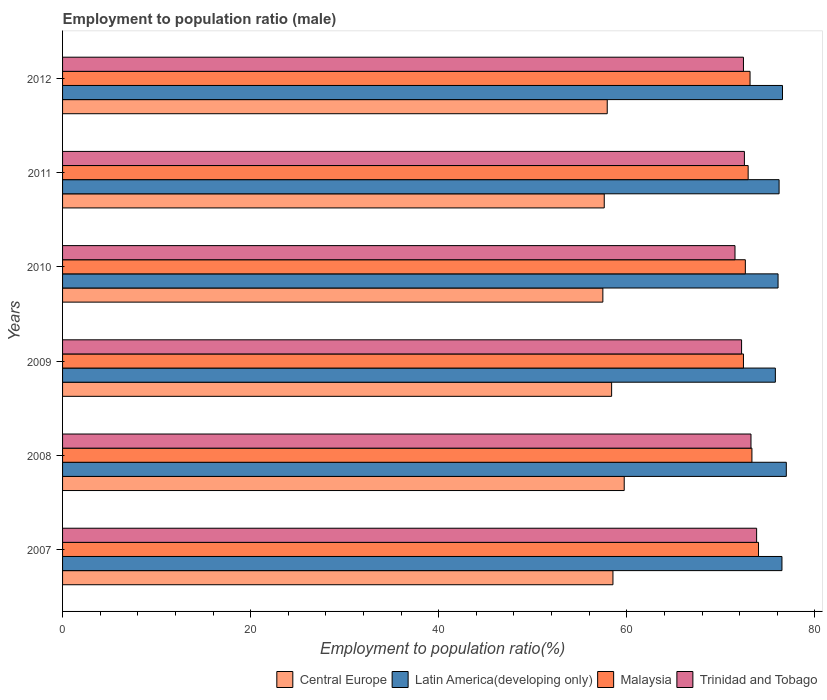How many groups of bars are there?
Your answer should be very brief. 6. Are the number of bars per tick equal to the number of legend labels?
Your answer should be very brief. Yes. How many bars are there on the 6th tick from the bottom?
Keep it short and to the point. 4. In how many cases, is the number of bars for a given year not equal to the number of legend labels?
Your answer should be very brief. 0. What is the employment to population ratio in Central Europe in 2012?
Offer a very short reply. 57.92. Across all years, what is the maximum employment to population ratio in Central Europe?
Provide a short and direct response. 59.72. Across all years, what is the minimum employment to population ratio in Central Europe?
Offer a terse response. 57.45. In which year was the employment to population ratio in Latin America(developing only) maximum?
Make the answer very short. 2008. In which year was the employment to population ratio in Latin America(developing only) minimum?
Provide a succinct answer. 2009. What is the total employment to population ratio in Malaysia in the graph?
Provide a short and direct response. 438.3. What is the difference between the employment to population ratio in Central Europe in 2008 and that in 2009?
Keep it short and to the point. 1.34. What is the difference between the employment to population ratio in Trinidad and Tobago in 2009 and the employment to population ratio in Latin America(developing only) in 2012?
Make the answer very short. -4.35. What is the average employment to population ratio in Central Europe per year?
Offer a very short reply. 58.26. In the year 2012, what is the difference between the employment to population ratio in Latin America(developing only) and employment to population ratio in Central Europe?
Your answer should be very brief. 18.63. In how many years, is the employment to population ratio in Malaysia greater than 28 %?
Ensure brevity in your answer.  6. What is the ratio of the employment to population ratio in Trinidad and Tobago in 2009 to that in 2010?
Offer a terse response. 1.01. Is the difference between the employment to population ratio in Latin America(developing only) in 2009 and 2011 greater than the difference between the employment to population ratio in Central Europe in 2009 and 2011?
Keep it short and to the point. No. What is the difference between the highest and the second highest employment to population ratio in Central Europe?
Your response must be concise. 1.2. What is the difference between the highest and the lowest employment to population ratio in Central Europe?
Offer a terse response. 2.27. In how many years, is the employment to population ratio in Trinidad and Tobago greater than the average employment to population ratio in Trinidad and Tobago taken over all years?
Ensure brevity in your answer.  2. Is the sum of the employment to population ratio in Malaysia in 2011 and 2012 greater than the maximum employment to population ratio in Central Europe across all years?
Give a very brief answer. Yes. Is it the case that in every year, the sum of the employment to population ratio in Central Europe and employment to population ratio in Latin America(developing only) is greater than the sum of employment to population ratio in Malaysia and employment to population ratio in Trinidad and Tobago?
Keep it short and to the point. Yes. What does the 3rd bar from the top in 2012 represents?
Keep it short and to the point. Latin America(developing only). What does the 3rd bar from the bottom in 2010 represents?
Ensure brevity in your answer.  Malaysia. How many bars are there?
Offer a very short reply. 24. Are all the bars in the graph horizontal?
Your answer should be very brief. Yes. How many years are there in the graph?
Your answer should be compact. 6. Are the values on the major ticks of X-axis written in scientific E-notation?
Provide a succinct answer. No. Does the graph contain any zero values?
Provide a short and direct response. No. How many legend labels are there?
Your answer should be compact. 4. What is the title of the graph?
Ensure brevity in your answer.  Employment to population ratio (male). What is the Employment to population ratio(%) in Central Europe in 2007?
Ensure brevity in your answer.  58.52. What is the Employment to population ratio(%) of Latin America(developing only) in 2007?
Your answer should be compact. 76.49. What is the Employment to population ratio(%) in Malaysia in 2007?
Your answer should be compact. 74. What is the Employment to population ratio(%) of Trinidad and Tobago in 2007?
Ensure brevity in your answer.  73.8. What is the Employment to population ratio(%) in Central Europe in 2008?
Your answer should be compact. 59.72. What is the Employment to population ratio(%) of Latin America(developing only) in 2008?
Give a very brief answer. 76.96. What is the Employment to population ratio(%) of Malaysia in 2008?
Provide a succinct answer. 73.3. What is the Employment to population ratio(%) of Trinidad and Tobago in 2008?
Keep it short and to the point. 73.2. What is the Employment to population ratio(%) in Central Europe in 2009?
Your response must be concise. 58.38. What is the Employment to population ratio(%) in Latin America(developing only) in 2009?
Your answer should be very brief. 75.79. What is the Employment to population ratio(%) in Malaysia in 2009?
Ensure brevity in your answer.  72.4. What is the Employment to population ratio(%) of Trinidad and Tobago in 2009?
Your answer should be very brief. 72.2. What is the Employment to population ratio(%) in Central Europe in 2010?
Ensure brevity in your answer.  57.45. What is the Employment to population ratio(%) in Latin America(developing only) in 2010?
Provide a short and direct response. 76.08. What is the Employment to population ratio(%) in Malaysia in 2010?
Ensure brevity in your answer.  72.6. What is the Employment to population ratio(%) of Trinidad and Tobago in 2010?
Make the answer very short. 71.5. What is the Employment to population ratio(%) of Central Europe in 2011?
Keep it short and to the point. 57.6. What is the Employment to population ratio(%) in Latin America(developing only) in 2011?
Your response must be concise. 76.19. What is the Employment to population ratio(%) in Malaysia in 2011?
Offer a terse response. 72.9. What is the Employment to population ratio(%) in Trinidad and Tobago in 2011?
Your answer should be compact. 72.5. What is the Employment to population ratio(%) of Central Europe in 2012?
Your response must be concise. 57.92. What is the Employment to population ratio(%) of Latin America(developing only) in 2012?
Your answer should be very brief. 76.55. What is the Employment to population ratio(%) in Malaysia in 2012?
Give a very brief answer. 73.1. What is the Employment to population ratio(%) in Trinidad and Tobago in 2012?
Your answer should be very brief. 72.4. Across all years, what is the maximum Employment to population ratio(%) in Central Europe?
Provide a succinct answer. 59.72. Across all years, what is the maximum Employment to population ratio(%) of Latin America(developing only)?
Ensure brevity in your answer.  76.96. Across all years, what is the maximum Employment to population ratio(%) of Trinidad and Tobago?
Offer a very short reply. 73.8. Across all years, what is the minimum Employment to population ratio(%) in Central Europe?
Keep it short and to the point. 57.45. Across all years, what is the minimum Employment to population ratio(%) of Latin America(developing only)?
Provide a succinct answer. 75.79. Across all years, what is the minimum Employment to population ratio(%) in Malaysia?
Give a very brief answer. 72.4. Across all years, what is the minimum Employment to population ratio(%) in Trinidad and Tobago?
Your response must be concise. 71.5. What is the total Employment to population ratio(%) of Central Europe in the graph?
Offer a terse response. 349.59. What is the total Employment to population ratio(%) in Latin America(developing only) in the graph?
Your answer should be compact. 458.06. What is the total Employment to population ratio(%) in Malaysia in the graph?
Offer a terse response. 438.3. What is the total Employment to population ratio(%) in Trinidad and Tobago in the graph?
Keep it short and to the point. 435.6. What is the difference between the Employment to population ratio(%) in Central Europe in 2007 and that in 2008?
Your response must be concise. -1.2. What is the difference between the Employment to population ratio(%) of Latin America(developing only) in 2007 and that in 2008?
Give a very brief answer. -0.46. What is the difference between the Employment to population ratio(%) of Malaysia in 2007 and that in 2008?
Provide a succinct answer. 0.7. What is the difference between the Employment to population ratio(%) in Central Europe in 2007 and that in 2009?
Your answer should be compact. 0.14. What is the difference between the Employment to population ratio(%) in Latin America(developing only) in 2007 and that in 2009?
Offer a very short reply. 0.7. What is the difference between the Employment to population ratio(%) in Malaysia in 2007 and that in 2009?
Ensure brevity in your answer.  1.6. What is the difference between the Employment to population ratio(%) in Central Europe in 2007 and that in 2010?
Offer a terse response. 1.07. What is the difference between the Employment to population ratio(%) in Latin America(developing only) in 2007 and that in 2010?
Your answer should be very brief. 0.41. What is the difference between the Employment to population ratio(%) of Malaysia in 2007 and that in 2010?
Your response must be concise. 1.4. What is the difference between the Employment to population ratio(%) in Trinidad and Tobago in 2007 and that in 2010?
Offer a terse response. 2.3. What is the difference between the Employment to population ratio(%) of Central Europe in 2007 and that in 2011?
Give a very brief answer. 0.92. What is the difference between the Employment to population ratio(%) of Latin America(developing only) in 2007 and that in 2011?
Offer a very short reply. 0.3. What is the difference between the Employment to population ratio(%) of Trinidad and Tobago in 2007 and that in 2011?
Ensure brevity in your answer.  1.3. What is the difference between the Employment to population ratio(%) of Central Europe in 2007 and that in 2012?
Provide a succinct answer. 0.61. What is the difference between the Employment to population ratio(%) of Latin America(developing only) in 2007 and that in 2012?
Keep it short and to the point. -0.06. What is the difference between the Employment to population ratio(%) in Malaysia in 2007 and that in 2012?
Provide a succinct answer. 0.9. What is the difference between the Employment to population ratio(%) of Trinidad and Tobago in 2007 and that in 2012?
Your answer should be compact. 1.4. What is the difference between the Employment to population ratio(%) of Central Europe in 2008 and that in 2009?
Make the answer very short. 1.34. What is the difference between the Employment to population ratio(%) of Latin America(developing only) in 2008 and that in 2009?
Ensure brevity in your answer.  1.16. What is the difference between the Employment to population ratio(%) of Central Europe in 2008 and that in 2010?
Your answer should be compact. 2.27. What is the difference between the Employment to population ratio(%) in Latin America(developing only) in 2008 and that in 2010?
Your answer should be very brief. 0.88. What is the difference between the Employment to population ratio(%) of Trinidad and Tobago in 2008 and that in 2010?
Give a very brief answer. 1.7. What is the difference between the Employment to population ratio(%) of Central Europe in 2008 and that in 2011?
Your answer should be compact. 2.12. What is the difference between the Employment to population ratio(%) in Latin America(developing only) in 2008 and that in 2011?
Offer a terse response. 0.77. What is the difference between the Employment to population ratio(%) of Trinidad and Tobago in 2008 and that in 2011?
Your response must be concise. 0.7. What is the difference between the Employment to population ratio(%) of Central Europe in 2008 and that in 2012?
Ensure brevity in your answer.  1.81. What is the difference between the Employment to population ratio(%) in Latin America(developing only) in 2008 and that in 2012?
Your response must be concise. 0.41. What is the difference between the Employment to population ratio(%) of Malaysia in 2008 and that in 2012?
Your answer should be compact. 0.2. What is the difference between the Employment to population ratio(%) of Trinidad and Tobago in 2008 and that in 2012?
Offer a very short reply. 0.8. What is the difference between the Employment to population ratio(%) in Latin America(developing only) in 2009 and that in 2010?
Offer a terse response. -0.29. What is the difference between the Employment to population ratio(%) in Malaysia in 2009 and that in 2010?
Offer a terse response. -0.2. What is the difference between the Employment to population ratio(%) in Central Europe in 2009 and that in 2011?
Ensure brevity in your answer.  0.78. What is the difference between the Employment to population ratio(%) of Latin America(developing only) in 2009 and that in 2011?
Provide a short and direct response. -0.4. What is the difference between the Employment to population ratio(%) of Trinidad and Tobago in 2009 and that in 2011?
Provide a short and direct response. -0.3. What is the difference between the Employment to population ratio(%) in Central Europe in 2009 and that in 2012?
Make the answer very short. 0.47. What is the difference between the Employment to population ratio(%) of Latin America(developing only) in 2009 and that in 2012?
Make the answer very short. -0.76. What is the difference between the Employment to population ratio(%) of Malaysia in 2009 and that in 2012?
Your answer should be compact. -0.7. What is the difference between the Employment to population ratio(%) in Trinidad and Tobago in 2009 and that in 2012?
Your response must be concise. -0.2. What is the difference between the Employment to population ratio(%) of Central Europe in 2010 and that in 2011?
Give a very brief answer. -0.15. What is the difference between the Employment to population ratio(%) of Latin America(developing only) in 2010 and that in 2011?
Give a very brief answer. -0.11. What is the difference between the Employment to population ratio(%) of Malaysia in 2010 and that in 2011?
Keep it short and to the point. -0.3. What is the difference between the Employment to population ratio(%) of Trinidad and Tobago in 2010 and that in 2011?
Your answer should be compact. -1. What is the difference between the Employment to population ratio(%) of Central Europe in 2010 and that in 2012?
Your answer should be very brief. -0.47. What is the difference between the Employment to population ratio(%) of Latin America(developing only) in 2010 and that in 2012?
Offer a terse response. -0.47. What is the difference between the Employment to population ratio(%) in Malaysia in 2010 and that in 2012?
Your answer should be very brief. -0.5. What is the difference between the Employment to population ratio(%) of Central Europe in 2011 and that in 2012?
Your response must be concise. -0.32. What is the difference between the Employment to population ratio(%) in Latin America(developing only) in 2011 and that in 2012?
Your answer should be very brief. -0.36. What is the difference between the Employment to population ratio(%) of Central Europe in 2007 and the Employment to population ratio(%) of Latin America(developing only) in 2008?
Offer a very short reply. -18.43. What is the difference between the Employment to population ratio(%) in Central Europe in 2007 and the Employment to population ratio(%) in Malaysia in 2008?
Ensure brevity in your answer.  -14.78. What is the difference between the Employment to population ratio(%) of Central Europe in 2007 and the Employment to population ratio(%) of Trinidad and Tobago in 2008?
Offer a terse response. -14.68. What is the difference between the Employment to population ratio(%) in Latin America(developing only) in 2007 and the Employment to population ratio(%) in Malaysia in 2008?
Keep it short and to the point. 3.19. What is the difference between the Employment to population ratio(%) of Latin America(developing only) in 2007 and the Employment to population ratio(%) of Trinidad and Tobago in 2008?
Your answer should be very brief. 3.29. What is the difference between the Employment to population ratio(%) in Central Europe in 2007 and the Employment to population ratio(%) in Latin America(developing only) in 2009?
Make the answer very short. -17.27. What is the difference between the Employment to population ratio(%) in Central Europe in 2007 and the Employment to population ratio(%) in Malaysia in 2009?
Offer a terse response. -13.88. What is the difference between the Employment to population ratio(%) in Central Europe in 2007 and the Employment to population ratio(%) in Trinidad and Tobago in 2009?
Provide a succinct answer. -13.68. What is the difference between the Employment to population ratio(%) in Latin America(developing only) in 2007 and the Employment to population ratio(%) in Malaysia in 2009?
Your answer should be very brief. 4.09. What is the difference between the Employment to population ratio(%) in Latin America(developing only) in 2007 and the Employment to population ratio(%) in Trinidad and Tobago in 2009?
Provide a succinct answer. 4.29. What is the difference between the Employment to population ratio(%) in Malaysia in 2007 and the Employment to population ratio(%) in Trinidad and Tobago in 2009?
Provide a succinct answer. 1.8. What is the difference between the Employment to population ratio(%) in Central Europe in 2007 and the Employment to population ratio(%) in Latin America(developing only) in 2010?
Make the answer very short. -17.56. What is the difference between the Employment to population ratio(%) of Central Europe in 2007 and the Employment to population ratio(%) of Malaysia in 2010?
Your response must be concise. -14.08. What is the difference between the Employment to population ratio(%) of Central Europe in 2007 and the Employment to population ratio(%) of Trinidad and Tobago in 2010?
Your answer should be compact. -12.98. What is the difference between the Employment to population ratio(%) of Latin America(developing only) in 2007 and the Employment to population ratio(%) of Malaysia in 2010?
Provide a succinct answer. 3.89. What is the difference between the Employment to population ratio(%) of Latin America(developing only) in 2007 and the Employment to population ratio(%) of Trinidad and Tobago in 2010?
Give a very brief answer. 4.99. What is the difference between the Employment to population ratio(%) of Malaysia in 2007 and the Employment to population ratio(%) of Trinidad and Tobago in 2010?
Make the answer very short. 2.5. What is the difference between the Employment to population ratio(%) of Central Europe in 2007 and the Employment to population ratio(%) of Latin America(developing only) in 2011?
Your response must be concise. -17.67. What is the difference between the Employment to population ratio(%) in Central Europe in 2007 and the Employment to population ratio(%) in Malaysia in 2011?
Provide a succinct answer. -14.38. What is the difference between the Employment to population ratio(%) of Central Europe in 2007 and the Employment to population ratio(%) of Trinidad and Tobago in 2011?
Offer a terse response. -13.98. What is the difference between the Employment to population ratio(%) of Latin America(developing only) in 2007 and the Employment to population ratio(%) of Malaysia in 2011?
Provide a succinct answer. 3.59. What is the difference between the Employment to population ratio(%) in Latin America(developing only) in 2007 and the Employment to population ratio(%) in Trinidad and Tobago in 2011?
Your answer should be compact. 3.99. What is the difference between the Employment to population ratio(%) of Malaysia in 2007 and the Employment to population ratio(%) of Trinidad and Tobago in 2011?
Offer a very short reply. 1.5. What is the difference between the Employment to population ratio(%) of Central Europe in 2007 and the Employment to population ratio(%) of Latin America(developing only) in 2012?
Offer a very short reply. -18.03. What is the difference between the Employment to population ratio(%) in Central Europe in 2007 and the Employment to population ratio(%) in Malaysia in 2012?
Offer a very short reply. -14.58. What is the difference between the Employment to population ratio(%) of Central Europe in 2007 and the Employment to population ratio(%) of Trinidad and Tobago in 2012?
Offer a very short reply. -13.88. What is the difference between the Employment to population ratio(%) of Latin America(developing only) in 2007 and the Employment to population ratio(%) of Malaysia in 2012?
Your response must be concise. 3.39. What is the difference between the Employment to population ratio(%) of Latin America(developing only) in 2007 and the Employment to population ratio(%) of Trinidad and Tobago in 2012?
Make the answer very short. 4.09. What is the difference between the Employment to population ratio(%) of Malaysia in 2007 and the Employment to population ratio(%) of Trinidad and Tobago in 2012?
Offer a very short reply. 1.6. What is the difference between the Employment to population ratio(%) in Central Europe in 2008 and the Employment to population ratio(%) in Latin America(developing only) in 2009?
Offer a very short reply. -16.07. What is the difference between the Employment to population ratio(%) of Central Europe in 2008 and the Employment to population ratio(%) of Malaysia in 2009?
Offer a very short reply. -12.68. What is the difference between the Employment to population ratio(%) in Central Europe in 2008 and the Employment to population ratio(%) in Trinidad and Tobago in 2009?
Your response must be concise. -12.48. What is the difference between the Employment to population ratio(%) of Latin America(developing only) in 2008 and the Employment to population ratio(%) of Malaysia in 2009?
Your response must be concise. 4.56. What is the difference between the Employment to population ratio(%) of Latin America(developing only) in 2008 and the Employment to population ratio(%) of Trinidad and Tobago in 2009?
Keep it short and to the point. 4.76. What is the difference between the Employment to population ratio(%) of Malaysia in 2008 and the Employment to population ratio(%) of Trinidad and Tobago in 2009?
Make the answer very short. 1.1. What is the difference between the Employment to population ratio(%) of Central Europe in 2008 and the Employment to population ratio(%) of Latin America(developing only) in 2010?
Give a very brief answer. -16.36. What is the difference between the Employment to population ratio(%) in Central Europe in 2008 and the Employment to population ratio(%) in Malaysia in 2010?
Your response must be concise. -12.88. What is the difference between the Employment to population ratio(%) of Central Europe in 2008 and the Employment to population ratio(%) of Trinidad and Tobago in 2010?
Offer a terse response. -11.78. What is the difference between the Employment to population ratio(%) of Latin America(developing only) in 2008 and the Employment to population ratio(%) of Malaysia in 2010?
Keep it short and to the point. 4.36. What is the difference between the Employment to population ratio(%) of Latin America(developing only) in 2008 and the Employment to population ratio(%) of Trinidad and Tobago in 2010?
Give a very brief answer. 5.46. What is the difference between the Employment to population ratio(%) of Malaysia in 2008 and the Employment to population ratio(%) of Trinidad and Tobago in 2010?
Make the answer very short. 1.8. What is the difference between the Employment to population ratio(%) in Central Europe in 2008 and the Employment to population ratio(%) in Latin America(developing only) in 2011?
Your answer should be very brief. -16.47. What is the difference between the Employment to population ratio(%) of Central Europe in 2008 and the Employment to population ratio(%) of Malaysia in 2011?
Offer a terse response. -13.18. What is the difference between the Employment to population ratio(%) of Central Europe in 2008 and the Employment to population ratio(%) of Trinidad and Tobago in 2011?
Ensure brevity in your answer.  -12.78. What is the difference between the Employment to population ratio(%) in Latin America(developing only) in 2008 and the Employment to population ratio(%) in Malaysia in 2011?
Offer a terse response. 4.06. What is the difference between the Employment to population ratio(%) in Latin America(developing only) in 2008 and the Employment to population ratio(%) in Trinidad and Tobago in 2011?
Your response must be concise. 4.46. What is the difference between the Employment to population ratio(%) in Central Europe in 2008 and the Employment to population ratio(%) in Latin America(developing only) in 2012?
Provide a succinct answer. -16.83. What is the difference between the Employment to population ratio(%) in Central Europe in 2008 and the Employment to population ratio(%) in Malaysia in 2012?
Provide a succinct answer. -13.38. What is the difference between the Employment to population ratio(%) in Central Europe in 2008 and the Employment to population ratio(%) in Trinidad and Tobago in 2012?
Your answer should be very brief. -12.68. What is the difference between the Employment to population ratio(%) of Latin America(developing only) in 2008 and the Employment to population ratio(%) of Malaysia in 2012?
Your answer should be compact. 3.86. What is the difference between the Employment to population ratio(%) in Latin America(developing only) in 2008 and the Employment to population ratio(%) in Trinidad and Tobago in 2012?
Make the answer very short. 4.56. What is the difference between the Employment to population ratio(%) in Central Europe in 2009 and the Employment to population ratio(%) in Latin America(developing only) in 2010?
Keep it short and to the point. -17.7. What is the difference between the Employment to population ratio(%) of Central Europe in 2009 and the Employment to population ratio(%) of Malaysia in 2010?
Offer a very short reply. -14.22. What is the difference between the Employment to population ratio(%) in Central Europe in 2009 and the Employment to population ratio(%) in Trinidad and Tobago in 2010?
Ensure brevity in your answer.  -13.12. What is the difference between the Employment to population ratio(%) of Latin America(developing only) in 2009 and the Employment to population ratio(%) of Malaysia in 2010?
Keep it short and to the point. 3.19. What is the difference between the Employment to population ratio(%) of Latin America(developing only) in 2009 and the Employment to population ratio(%) of Trinidad and Tobago in 2010?
Keep it short and to the point. 4.29. What is the difference between the Employment to population ratio(%) in Malaysia in 2009 and the Employment to population ratio(%) in Trinidad and Tobago in 2010?
Give a very brief answer. 0.9. What is the difference between the Employment to population ratio(%) of Central Europe in 2009 and the Employment to population ratio(%) of Latin America(developing only) in 2011?
Your response must be concise. -17.81. What is the difference between the Employment to population ratio(%) in Central Europe in 2009 and the Employment to population ratio(%) in Malaysia in 2011?
Provide a succinct answer. -14.52. What is the difference between the Employment to population ratio(%) of Central Europe in 2009 and the Employment to population ratio(%) of Trinidad and Tobago in 2011?
Offer a very short reply. -14.12. What is the difference between the Employment to population ratio(%) of Latin America(developing only) in 2009 and the Employment to population ratio(%) of Malaysia in 2011?
Your answer should be very brief. 2.89. What is the difference between the Employment to population ratio(%) of Latin America(developing only) in 2009 and the Employment to population ratio(%) of Trinidad and Tobago in 2011?
Your response must be concise. 3.29. What is the difference between the Employment to population ratio(%) in Malaysia in 2009 and the Employment to population ratio(%) in Trinidad and Tobago in 2011?
Your answer should be very brief. -0.1. What is the difference between the Employment to population ratio(%) in Central Europe in 2009 and the Employment to population ratio(%) in Latin America(developing only) in 2012?
Offer a very short reply. -18.17. What is the difference between the Employment to population ratio(%) in Central Europe in 2009 and the Employment to population ratio(%) in Malaysia in 2012?
Give a very brief answer. -14.72. What is the difference between the Employment to population ratio(%) in Central Europe in 2009 and the Employment to population ratio(%) in Trinidad and Tobago in 2012?
Give a very brief answer. -14.02. What is the difference between the Employment to population ratio(%) in Latin America(developing only) in 2009 and the Employment to population ratio(%) in Malaysia in 2012?
Make the answer very short. 2.69. What is the difference between the Employment to population ratio(%) in Latin America(developing only) in 2009 and the Employment to population ratio(%) in Trinidad and Tobago in 2012?
Provide a succinct answer. 3.39. What is the difference between the Employment to population ratio(%) of Central Europe in 2010 and the Employment to population ratio(%) of Latin America(developing only) in 2011?
Provide a succinct answer. -18.74. What is the difference between the Employment to population ratio(%) in Central Europe in 2010 and the Employment to population ratio(%) in Malaysia in 2011?
Provide a succinct answer. -15.45. What is the difference between the Employment to population ratio(%) in Central Europe in 2010 and the Employment to population ratio(%) in Trinidad and Tobago in 2011?
Offer a very short reply. -15.05. What is the difference between the Employment to population ratio(%) of Latin America(developing only) in 2010 and the Employment to population ratio(%) of Malaysia in 2011?
Offer a very short reply. 3.18. What is the difference between the Employment to population ratio(%) in Latin America(developing only) in 2010 and the Employment to population ratio(%) in Trinidad and Tobago in 2011?
Your response must be concise. 3.58. What is the difference between the Employment to population ratio(%) in Central Europe in 2010 and the Employment to population ratio(%) in Latin America(developing only) in 2012?
Your answer should be compact. -19.1. What is the difference between the Employment to population ratio(%) in Central Europe in 2010 and the Employment to population ratio(%) in Malaysia in 2012?
Offer a terse response. -15.65. What is the difference between the Employment to population ratio(%) in Central Europe in 2010 and the Employment to population ratio(%) in Trinidad and Tobago in 2012?
Keep it short and to the point. -14.95. What is the difference between the Employment to population ratio(%) of Latin America(developing only) in 2010 and the Employment to population ratio(%) of Malaysia in 2012?
Your answer should be compact. 2.98. What is the difference between the Employment to population ratio(%) in Latin America(developing only) in 2010 and the Employment to population ratio(%) in Trinidad and Tobago in 2012?
Provide a short and direct response. 3.68. What is the difference between the Employment to population ratio(%) of Malaysia in 2010 and the Employment to population ratio(%) of Trinidad and Tobago in 2012?
Keep it short and to the point. 0.2. What is the difference between the Employment to population ratio(%) of Central Europe in 2011 and the Employment to population ratio(%) of Latin America(developing only) in 2012?
Make the answer very short. -18.95. What is the difference between the Employment to population ratio(%) of Central Europe in 2011 and the Employment to population ratio(%) of Malaysia in 2012?
Provide a short and direct response. -15.5. What is the difference between the Employment to population ratio(%) in Central Europe in 2011 and the Employment to population ratio(%) in Trinidad and Tobago in 2012?
Your answer should be compact. -14.8. What is the difference between the Employment to population ratio(%) in Latin America(developing only) in 2011 and the Employment to population ratio(%) in Malaysia in 2012?
Your answer should be compact. 3.09. What is the difference between the Employment to population ratio(%) in Latin America(developing only) in 2011 and the Employment to population ratio(%) in Trinidad and Tobago in 2012?
Give a very brief answer. 3.79. What is the difference between the Employment to population ratio(%) in Malaysia in 2011 and the Employment to population ratio(%) in Trinidad and Tobago in 2012?
Make the answer very short. 0.5. What is the average Employment to population ratio(%) in Central Europe per year?
Your answer should be very brief. 58.26. What is the average Employment to population ratio(%) in Latin America(developing only) per year?
Offer a terse response. 76.34. What is the average Employment to population ratio(%) in Malaysia per year?
Offer a very short reply. 73.05. What is the average Employment to population ratio(%) in Trinidad and Tobago per year?
Provide a succinct answer. 72.6. In the year 2007, what is the difference between the Employment to population ratio(%) of Central Europe and Employment to population ratio(%) of Latin America(developing only)?
Ensure brevity in your answer.  -17.97. In the year 2007, what is the difference between the Employment to population ratio(%) of Central Europe and Employment to population ratio(%) of Malaysia?
Your answer should be very brief. -15.48. In the year 2007, what is the difference between the Employment to population ratio(%) in Central Europe and Employment to population ratio(%) in Trinidad and Tobago?
Offer a terse response. -15.28. In the year 2007, what is the difference between the Employment to population ratio(%) of Latin America(developing only) and Employment to population ratio(%) of Malaysia?
Ensure brevity in your answer.  2.49. In the year 2007, what is the difference between the Employment to population ratio(%) in Latin America(developing only) and Employment to population ratio(%) in Trinidad and Tobago?
Provide a succinct answer. 2.69. In the year 2007, what is the difference between the Employment to population ratio(%) in Malaysia and Employment to population ratio(%) in Trinidad and Tobago?
Provide a succinct answer. 0.2. In the year 2008, what is the difference between the Employment to population ratio(%) of Central Europe and Employment to population ratio(%) of Latin America(developing only)?
Offer a terse response. -17.23. In the year 2008, what is the difference between the Employment to population ratio(%) in Central Europe and Employment to population ratio(%) in Malaysia?
Your answer should be compact. -13.58. In the year 2008, what is the difference between the Employment to population ratio(%) of Central Europe and Employment to population ratio(%) of Trinidad and Tobago?
Provide a succinct answer. -13.48. In the year 2008, what is the difference between the Employment to population ratio(%) in Latin America(developing only) and Employment to population ratio(%) in Malaysia?
Offer a very short reply. 3.66. In the year 2008, what is the difference between the Employment to population ratio(%) of Latin America(developing only) and Employment to population ratio(%) of Trinidad and Tobago?
Offer a very short reply. 3.76. In the year 2009, what is the difference between the Employment to population ratio(%) in Central Europe and Employment to population ratio(%) in Latin America(developing only)?
Make the answer very short. -17.41. In the year 2009, what is the difference between the Employment to population ratio(%) of Central Europe and Employment to population ratio(%) of Malaysia?
Keep it short and to the point. -14.02. In the year 2009, what is the difference between the Employment to population ratio(%) in Central Europe and Employment to population ratio(%) in Trinidad and Tobago?
Your response must be concise. -13.82. In the year 2009, what is the difference between the Employment to population ratio(%) of Latin America(developing only) and Employment to population ratio(%) of Malaysia?
Provide a short and direct response. 3.39. In the year 2009, what is the difference between the Employment to population ratio(%) of Latin America(developing only) and Employment to population ratio(%) of Trinidad and Tobago?
Offer a very short reply. 3.59. In the year 2010, what is the difference between the Employment to population ratio(%) in Central Europe and Employment to population ratio(%) in Latin America(developing only)?
Your answer should be very brief. -18.63. In the year 2010, what is the difference between the Employment to population ratio(%) of Central Europe and Employment to population ratio(%) of Malaysia?
Your response must be concise. -15.15. In the year 2010, what is the difference between the Employment to population ratio(%) of Central Europe and Employment to population ratio(%) of Trinidad and Tobago?
Ensure brevity in your answer.  -14.05. In the year 2010, what is the difference between the Employment to population ratio(%) of Latin America(developing only) and Employment to population ratio(%) of Malaysia?
Provide a succinct answer. 3.48. In the year 2010, what is the difference between the Employment to population ratio(%) of Latin America(developing only) and Employment to population ratio(%) of Trinidad and Tobago?
Your response must be concise. 4.58. In the year 2011, what is the difference between the Employment to population ratio(%) in Central Europe and Employment to population ratio(%) in Latin America(developing only)?
Give a very brief answer. -18.59. In the year 2011, what is the difference between the Employment to population ratio(%) of Central Europe and Employment to population ratio(%) of Malaysia?
Make the answer very short. -15.3. In the year 2011, what is the difference between the Employment to population ratio(%) in Central Europe and Employment to population ratio(%) in Trinidad and Tobago?
Give a very brief answer. -14.9. In the year 2011, what is the difference between the Employment to population ratio(%) in Latin America(developing only) and Employment to population ratio(%) in Malaysia?
Provide a short and direct response. 3.29. In the year 2011, what is the difference between the Employment to population ratio(%) of Latin America(developing only) and Employment to population ratio(%) of Trinidad and Tobago?
Give a very brief answer. 3.69. In the year 2011, what is the difference between the Employment to population ratio(%) of Malaysia and Employment to population ratio(%) of Trinidad and Tobago?
Your answer should be compact. 0.4. In the year 2012, what is the difference between the Employment to population ratio(%) in Central Europe and Employment to population ratio(%) in Latin America(developing only)?
Make the answer very short. -18.63. In the year 2012, what is the difference between the Employment to population ratio(%) of Central Europe and Employment to population ratio(%) of Malaysia?
Keep it short and to the point. -15.18. In the year 2012, what is the difference between the Employment to population ratio(%) in Central Europe and Employment to population ratio(%) in Trinidad and Tobago?
Offer a terse response. -14.48. In the year 2012, what is the difference between the Employment to population ratio(%) in Latin America(developing only) and Employment to population ratio(%) in Malaysia?
Ensure brevity in your answer.  3.45. In the year 2012, what is the difference between the Employment to population ratio(%) of Latin America(developing only) and Employment to population ratio(%) of Trinidad and Tobago?
Ensure brevity in your answer.  4.15. In the year 2012, what is the difference between the Employment to population ratio(%) of Malaysia and Employment to population ratio(%) of Trinidad and Tobago?
Your answer should be very brief. 0.7. What is the ratio of the Employment to population ratio(%) in Central Europe in 2007 to that in 2008?
Make the answer very short. 0.98. What is the ratio of the Employment to population ratio(%) in Malaysia in 2007 to that in 2008?
Your response must be concise. 1.01. What is the ratio of the Employment to population ratio(%) of Trinidad and Tobago in 2007 to that in 2008?
Offer a very short reply. 1.01. What is the ratio of the Employment to population ratio(%) in Latin America(developing only) in 2007 to that in 2009?
Make the answer very short. 1.01. What is the ratio of the Employment to population ratio(%) of Malaysia in 2007 to that in 2009?
Your response must be concise. 1.02. What is the ratio of the Employment to population ratio(%) of Trinidad and Tobago in 2007 to that in 2009?
Provide a short and direct response. 1.02. What is the ratio of the Employment to population ratio(%) in Central Europe in 2007 to that in 2010?
Provide a succinct answer. 1.02. What is the ratio of the Employment to population ratio(%) in Latin America(developing only) in 2007 to that in 2010?
Offer a very short reply. 1.01. What is the ratio of the Employment to population ratio(%) in Malaysia in 2007 to that in 2010?
Your answer should be very brief. 1.02. What is the ratio of the Employment to population ratio(%) of Trinidad and Tobago in 2007 to that in 2010?
Your answer should be compact. 1.03. What is the ratio of the Employment to population ratio(%) of Latin America(developing only) in 2007 to that in 2011?
Ensure brevity in your answer.  1. What is the ratio of the Employment to population ratio(%) of Malaysia in 2007 to that in 2011?
Give a very brief answer. 1.02. What is the ratio of the Employment to population ratio(%) of Trinidad and Tobago in 2007 to that in 2011?
Your response must be concise. 1.02. What is the ratio of the Employment to population ratio(%) of Central Europe in 2007 to that in 2012?
Give a very brief answer. 1.01. What is the ratio of the Employment to population ratio(%) in Latin America(developing only) in 2007 to that in 2012?
Your answer should be compact. 1. What is the ratio of the Employment to population ratio(%) in Malaysia in 2007 to that in 2012?
Ensure brevity in your answer.  1.01. What is the ratio of the Employment to population ratio(%) of Trinidad and Tobago in 2007 to that in 2012?
Keep it short and to the point. 1.02. What is the ratio of the Employment to population ratio(%) in Central Europe in 2008 to that in 2009?
Your answer should be compact. 1.02. What is the ratio of the Employment to population ratio(%) of Latin America(developing only) in 2008 to that in 2009?
Your response must be concise. 1.02. What is the ratio of the Employment to population ratio(%) of Malaysia in 2008 to that in 2009?
Your response must be concise. 1.01. What is the ratio of the Employment to population ratio(%) in Trinidad and Tobago in 2008 to that in 2009?
Offer a very short reply. 1.01. What is the ratio of the Employment to population ratio(%) in Central Europe in 2008 to that in 2010?
Your answer should be very brief. 1.04. What is the ratio of the Employment to population ratio(%) of Latin America(developing only) in 2008 to that in 2010?
Provide a short and direct response. 1.01. What is the ratio of the Employment to population ratio(%) of Malaysia in 2008 to that in 2010?
Provide a short and direct response. 1.01. What is the ratio of the Employment to population ratio(%) in Trinidad and Tobago in 2008 to that in 2010?
Offer a very short reply. 1.02. What is the ratio of the Employment to population ratio(%) of Central Europe in 2008 to that in 2011?
Your answer should be compact. 1.04. What is the ratio of the Employment to population ratio(%) of Malaysia in 2008 to that in 2011?
Your answer should be compact. 1.01. What is the ratio of the Employment to population ratio(%) of Trinidad and Tobago in 2008 to that in 2011?
Make the answer very short. 1.01. What is the ratio of the Employment to population ratio(%) in Central Europe in 2008 to that in 2012?
Your response must be concise. 1.03. What is the ratio of the Employment to population ratio(%) in Latin America(developing only) in 2008 to that in 2012?
Your response must be concise. 1.01. What is the ratio of the Employment to population ratio(%) of Trinidad and Tobago in 2008 to that in 2012?
Your answer should be very brief. 1.01. What is the ratio of the Employment to population ratio(%) in Central Europe in 2009 to that in 2010?
Offer a very short reply. 1.02. What is the ratio of the Employment to population ratio(%) of Latin America(developing only) in 2009 to that in 2010?
Offer a very short reply. 1. What is the ratio of the Employment to population ratio(%) in Trinidad and Tobago in 2009 to that in 2010?
Offer a terse response. 1.01. What is the ratio of the Employment to population ratio(%) in Central Europe in 2009 to that in 2011?
Offer a very short reply. 1.01. What is the ratio of the Employment to population ratio(%) of Malaysia in 2009 to that in 2011?
Your response must be concise. 0.99. What is the ratio of the Employment to population ratio(%) of Trinidad and Tobago in 2009 to that in 2011?
Your answer should be compact. 1. What is the ratio of the Employment to population ratio(%) in Central Europe in 2009 to that in 2012?
Provide a succinct answer. 1.01. What is the ratio of the Employment to population ratio(%) of Latin America(developing only) in 2009 to that in 2012?
Ensure brevity in your answer.  0.99. What is the ratio of the Employment to population ratio(%) in Central Europe in 2010 to that in 2011?
Provide a short and direct response. 1. What is the ratio of the Employment to population ratio(%) of Latin America(developing only) in 2010 to that in 2011?
Make the answer very short. 1. What is the ratio of the Employment to population ratio(%) of Malaysia in 2010 to that in 2011?
Keep it short and to the point. 1. What is the ratio of the Employment to population ratio(%) of Trinidad and Tobago in 2010 to that in 2011?
Your response must be concise. 0.99. What is the ratio of the Employment to population ratio(%) of Central Europe in 2010 to that in 2012?
Your response must be concise. 0.99. What is the ratio of the Employment to population ratio(%) of Malaysia in 2010 to that in 2012?
Ensure brevity in your answer.  0.99. What is the ratio of the Employment to population ratio(%) of Trinidad and Tobago in 2010 to that in 2012?
Make the answer very short. 0.99. What is the ratio of the Employment to population ratio(%) in Latin America(developing only) in 2011 to that in 2012?
Provide a succinct answer. 1. What is the ratio of the Employment to population ratio(%) in Malaysia in 2011 to that in 2012?
Keep it short and to the point. 1. What is the difference between the highest and the second highest Employment to population ratio(%) of Central Europe?
Provide a short and direct response. 1.2. What is the difference between the highest and the second highest Employment to population ratio(%) in Latin America(developing only)?
Offer a very short reply. 0.41. What is the difference between the highest and the lowest Employment to population ratio(%) in Central Europe?
Provide a short and direct response. 2.27. What is the difference between the highest and the lowest Employment to population ratio(%) of Latin America(developing only)?
Make the answer very short. 1.16. 